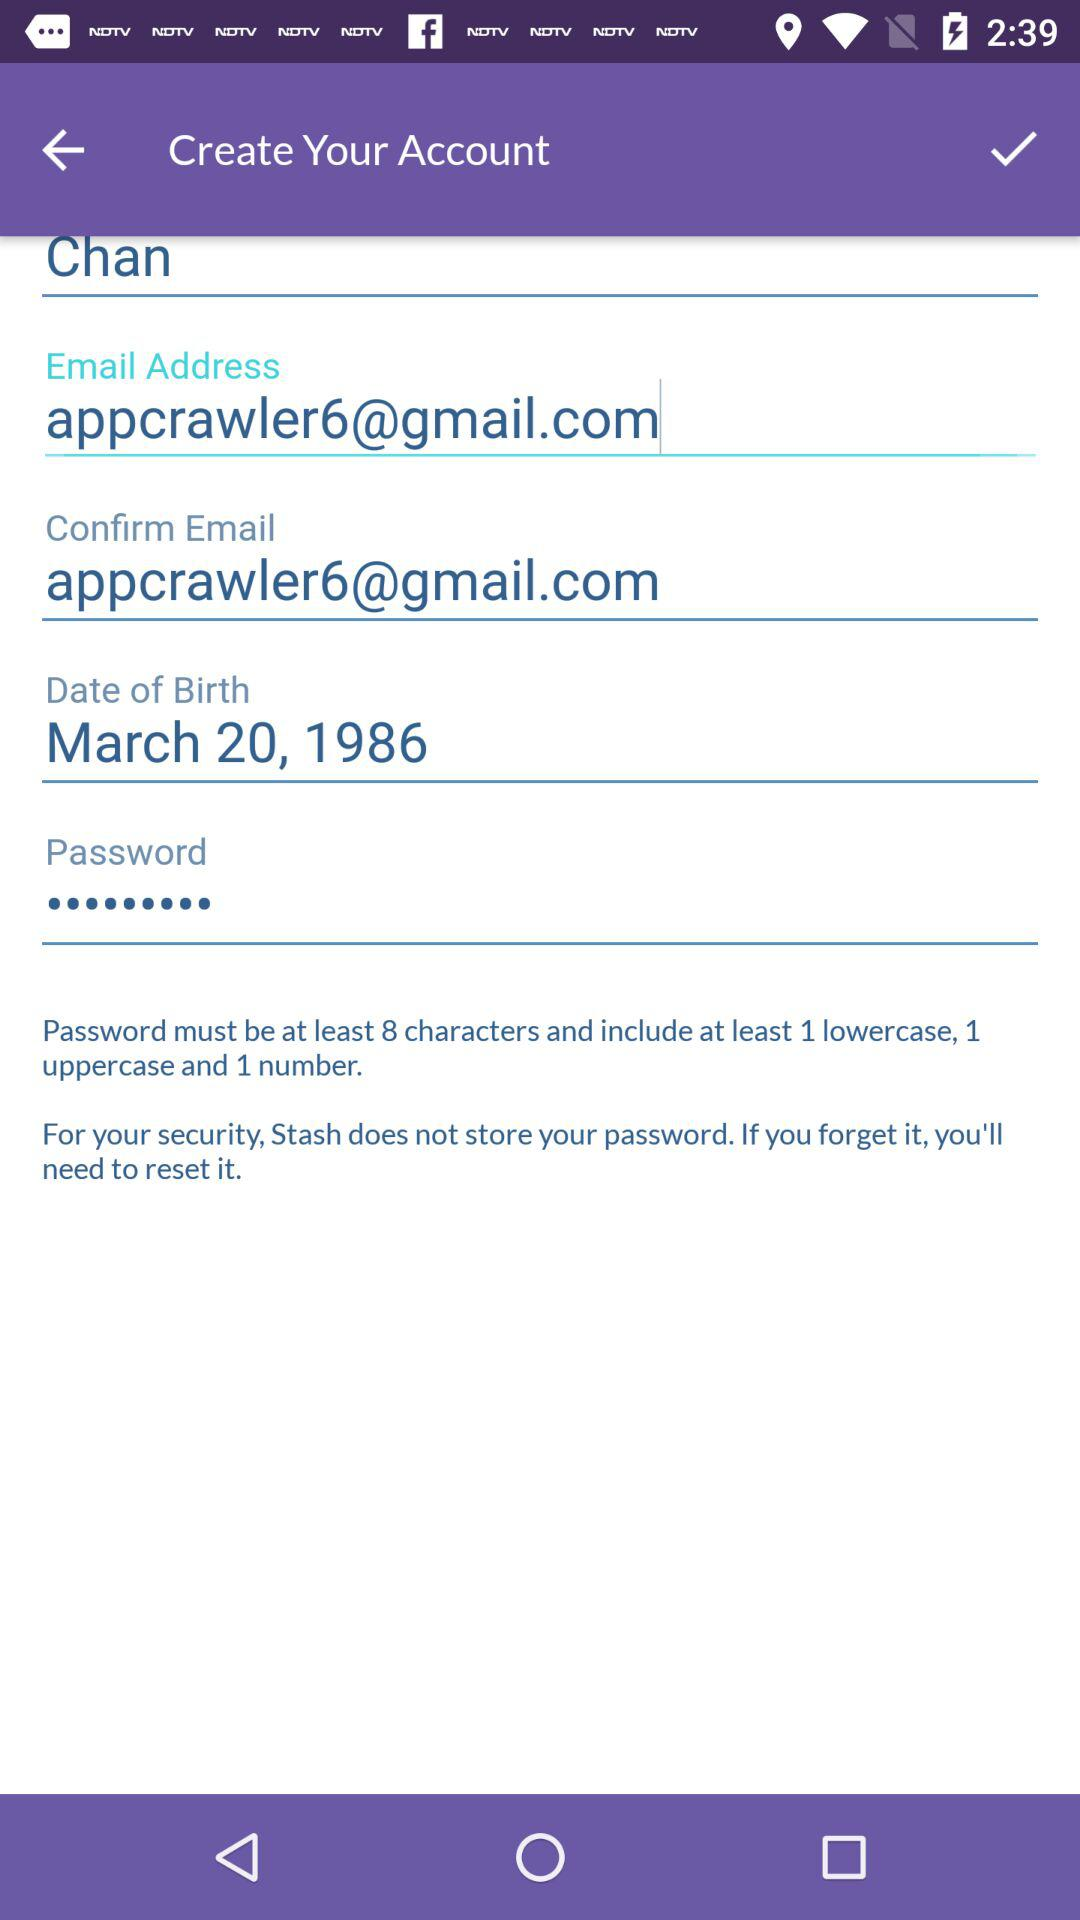How many least characters are required in the password? At least 8 characters are required in the password. 